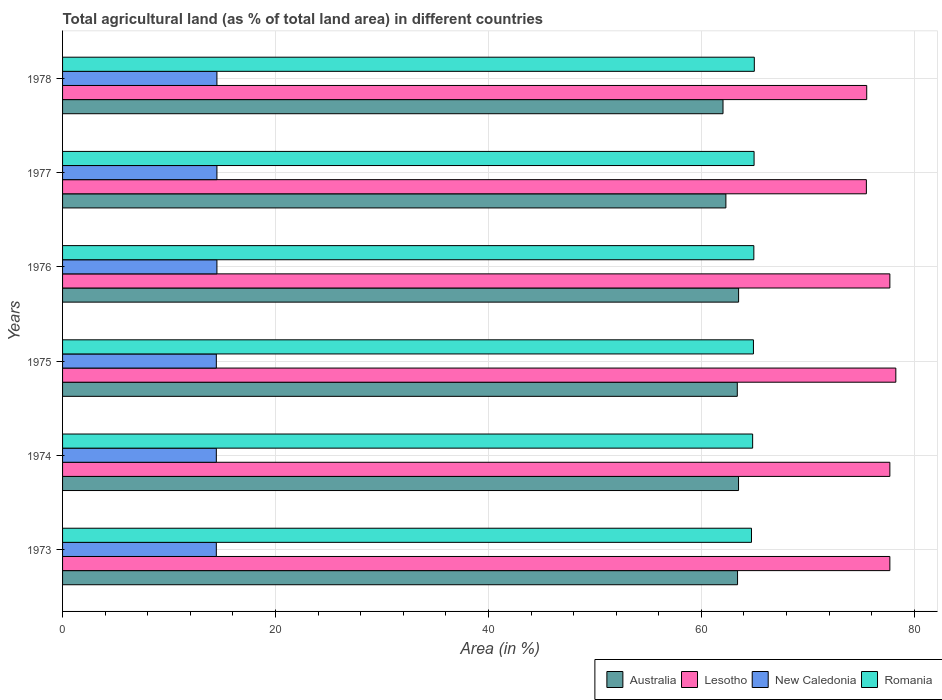How many bars are there on the 4th tick from the bottom?
Your response must be concise. 4. What is the label of the 1st group of bars from the top?
Your answer should be compact. 1978. What is the percentage of agricultural land in New Caledonia in 1975?
Your answer should be very brief. 14.44. Across all years, what is the maximum percentage of agricultural land in Lesotho?
Provide a short and direct response. 78.26. Across all years, what is the minimum percentage of agricultural land in Romania?
Offer a very short reply. 64.7. In which year was the percentage of agricultural land in Lesotho maximum?
Provide a short and direct response. 1975. In which year was the percentage of agricultural land in Australia minimum?
Make the answer very short. 1978. What is the total percentage of agricultural land in New Caledonia in the graph?
Keep it short and to the point. 86.82. What is the difference between the percentage of agricultural land in Australia in 1975 and that in 1978?
Offer a terse response. 1.34. What is the difference between the percentage of agricultural land in Romania in 1976 and the percentage of agricultural land in Australia in 1974?
Make the answer very short. 1.44. What is the average percentage of agricultural land in Lesotho per year?
Provide a succinct answer. 77.06. In the year 1976, what is the difference between the percentage of agricultural land in Australia and percentage of agricultural land in Romania?
Your answer should be very brief. -1.43. What is the ratio of the percentage of agricultural land in Australia in 1973 to that in 1978?
Offer a very short reply. 1.02. Is the percentage of agricultural land in Australia in 1975 less than that in 1978?
Your answer should be very brief. No. Is the difference between the percentage of agricultural land in Australia in 1977 and 1978 greater than the difference between the percentage of agricultural land in Romania in 1977 and 1978?
Your response must be concise. Yes. What is the difference between the highest and the second highest percentage of agricultural land in Australia?
Provide a short and direct response. 0.01. What is the difference between the highest and the lowest percentage of agricultural land in Australia?
Provide a short and direct response. 1.46. Is the sum of the percentage of agricultural land in Lesotho in 1976 and 1977 greater than the maximum percentage of agricultural land in Australia across all years?
Offer a terse response. Yes. What does the 2nd bar from the bottom in 1973 represents?
Give a very brief answer. Lesotho. Is it the case that in every year, the sum of the percentage of agricultural land in Australia and percentage of agricultural land in New Caledonia is greater than the percentage of agricultural land in Lesotho?
Your answer should be compact. No. Are the values on the major ticks of X-axis written in scientific E-notation?
Your answer should be very brief. No. Does the graph contain any zero values?
Your answer should be very brief. No. How many legend labels are there?
Your answer should be very brief. 4. What is the title of the graph?
Offer a very short reply. Total agricultural land (as % of total land area) in different countries. What is the label or title of the X-axis?
Your answer should be compact. Area (in %). What is the Area (in %) of Australia in 1973?
Ensure brevity in your answer.  63.39. What is the Area (in %) in Lesotho in 1973?
Offer a terse response. 77.7. What is the Area (in %) in New Caledonia in 1973?
Keep it short and to the point. 14.44. What is the Area (in %) of Romania in 1973?
Keep it short and to the point. 64.7. What is the Area (in %) in Australia in 1974?
Your answer should be compact. 63.49. What is the Area (in %) in Lesotho in 1974?
Provide a short and direct response. 77.7. What is the Area (in %) in New Caledonia in 1974?
Your answer should be compact. 14.44. What is the Area (in %) in Romania in 1974?
Offer a very short reply. 64.81. What is the Area (in %) of Australia in 1975?
Your answer should be compact. 63.37. What is the Area (in %) of Lesotho in 1975?
Your response must be concise. 78.26. What is the Area (in %) in New Caledonia in 1975?
Your response must be concise. 14.44. What is the Area (in %) in Romania in 1975?
Your response must be concise. 64.89. What is the Area (in %) of Australia in 1976?
Keep it short and to the point. 63.49. What is the Area (in %) in Lesotho in 1976?
Keep it short and to the point. 77.7. What is the Area (in %) in New Caledonia in 1976?
Give a very brief answer. 14.5. What is the Area (in %) in Romania in 1976?
Your response must be concise. 64.93. What is the Area (in %) in Australia in 1977?
Provide a succinct answer. 62.3. What is the Area (in %) of Lesotho in 1977?
Your answer should be compact. 75.49. What is the Area (in %) in New Caledonia in 1977?
Your answer should be compact. 14.5. What is the Area (in %) of Romania in 1977?
Make the answer very short. 64.95. What is the Area (in %) in Australia in 1978?
Provide a succinct answer. 62.03. What is the Area (in %) of Lesotho in 1978?
Offer a terse response. 75.53. What is the Area (in %) in New Caledonia in 1978?
Provide a succinct answer. 14.5. What is the Area (in %) of Romania in 1978?
Provide a succinct answer. 64.97. Across all years, what is the maximum Area (in %) of Australia?
Your response must be concise. 63.49. Across all years, what is the maximum Area (in %) in Lesotho?
Give a very brief answer. 78.26. Across all years, what is the maximum Area (in %) in New Caledonia?
Your answer should be compact. 14.5. Across all years, what is the maximum Area (in %) in Romania?
Make the answer very short. 64.97. Across all years, what is the minimum Area (in %) of Australia?
Give a very brief answer. 62.03. Across all years, what is the minimum Area (in %) of Lesotho?
Keep it short and to the point. 75.49. Across all years, what is the minimum Area (in %) of New Caledonia?
Provide a succinct answer. 14.44. Across all years, what is the minimum Area (in %) of Romania?
Your answer should be very brief. 64.7. What is the total Area (in %) in Australia in the graph?
Provide a short and direct response. 378.08. What is the total Area (in %) of Lesotho in the graph?
Your answer should be compact. 462.38. What is the total Area (in %) in New Caledonia in the graph?
Offer a terse response. 86.82. What is the total Area (in %) of Romania in the graph?
Ensure brevity in your answer.  389.25. What is the difference between the Area (in %) in Australia in 1973 and that in 1974?
Offer a very short reply. -0.09. What is the difference between the Area (in %) in Lesotho in 1973 and that in 1974?
Make the answer very short. 0. What is the difference between the Area (in %) of Romania in 1973 and that in 1974?
Ensure brevity in your answer.  -0.11. What is the difference between the Area (in %) of Australia in 1973 and that in 1975?
Keep it short and to the point. 0.02. What is the difference between the Area (in %) in Lesotho in 1973 and that in 1975?
Provide a short and direct response. -0.56. What is the difference between the Area (in %) in New Caledonia in 1973 and that in 1975?
Keep it short and to the point. 0. What is the difference between the Area (in %) in Romania in 1973 and that in 1975?
Offer a very short reply. -0.18. What is the difference between the Area (in %) of Australia in 1973 and that in 1976?
Keep it short and to the point. -0.1. What is the difference between the Area (in %) in New Caledonia in 1973 and that in 1976?
Provide a succinct answer. -0.05. What is the difference between the Area (in %) of Romania in 1973 and that in 1976?
Make the answer very short. -0.22. What is the difference between the Area (in %) of Australia in 1973 and that in 1977?
Give a very brief answer. 1.09. What is the difference between the Area (in %) in Lesotho in 1973 and that in 1977?
Keep it short and to the point. 2.21. What is the difference between the Area (in %) in New Caledonia in 1973 and that in 1977?
Your response must be concise. -0.05. What is the difference between the Area (in %) of Romania in 1973 and that in 1977?
Keep it short and to the point. -0.24. What is the difference between the Area (in %) in Australia in 1973 and that in 1978?
Offer a terse response. 1.37. What is the difference between the Area (in %) in Lesotho in 1973 and that in 1978?
Your answer should be compact. 2.17. What is the difference between the Area (in %) of New Caledonia in 1973 and that in 1978?
Offer a terse response. -0.05. What is the difference between the Area (in %) in Romania in 1973 and that in 1978?
Make the answer very short. -0.26. What is the difference between the Area (in %) of Australia in 1974 and that in 1975?
Offer a terse response. 0.12. What is the difference between the Area (in %) in Lesotho in 1974 and that in 1975?
Give a very brief answer. -0.56. What is the difference between the Area (in %) in Romania in 1974 and that in 1975?
Provide a succinct answer. -0.07. What is the difference between the Area (in %) in Australia in 1974 and that in 1976?
Provide a short and direct response. -0.01. What is the difference between the Area (in %) in New Caledonia in 1974 and that in 1976?
Provide a succinct answer. -0.05. What is the difference between the Area (in %) of Romania in 1974 and that in 1976?
Make the answer very short. -0.11. What is the difference between the Area (in %) in Australia in 1974 and that in 1977?
Make the answer very short. 1.19. What is the difference between the Area (in %) of Lesotho in 1974 and that in 1977?
Give a very brief answer. 2.21. What is the difference between the Area (in %) in New Caledonia in 1974 and that in 1977?
Offer a very short reply. -0.05. What is the difference between the Area (in %) in Romania in 1974 and that in 1977?
Ensure brevity in your answer.  -0.13. What is the difference between the Area (in %) of Australia in 1974 and that in 1978?
Offer a terse response. 1.46. What is the difference between the Area (in %) in Lesotho in 1974 and that in 1978?
Keep it short and to the point. 2.17. What is the difference between the Area (in %) in New Caledonia in 1974 and that in 1978?
Your answer should be very brief. -0.05. What is the difference between the Area (in %) of Romania in 1974 and that in 1978?
Ensure brevity in your answer.  -0.16. What is the difference between the Area (in %) of Australia in 1975 and that in 1976?
Give a very brief answer. -0.12. What is the difference between the Area (in %) in Lesotho in 1975 and that in 1976?
Your answer should be very brief. 0.56. What is the difference between the Area (in %) in New Caledonia in 1975 and that in 1976?
Give a very brief answer. -0.05. What is the difference between the Area (in %) in Romania in 1975 and that in 1976?
Make the answer very short. -0.04. What is the difference between the Area (in %) of Australia in 1975 and that in 1977?
Offer a very short reply. 1.07. What is the difference between the Area (in %) of Lesotho in 1975 and that in 1977?
Your answer should be very brief. 2.77. What is the difference between the Area (in %) in New Caledonia in 1975 and that in 1977?
Give a very brief answer. -0.05. What is the difference between the Area (in %) in Romania in 1975 and that in 1977?
Ensure brevity in your answer.  -0.06. What is the difference between the Area (in %) in Australia in 1975 and that in 1978?
Offer a terse response. 1.34. What is the difference between the Area (in %) of Lesotho in 1975 and that in 1978?
Offer a terse response. 2.73. What is the difference between the Area (in %) of New Caledonia in 1975 and that in 1978?
Make the answer very short. -0.05. What is the difference between the Area (in %) in Romania in 1975 and that in 1978?
Your answer should be compact. -0.08. What is the difference between the Area (in %) in Australia in 1976 and that in 1977?
Provide a short and direct response. 1.19. What is the difference between the Area (in %) in Lesotho in 1976 and that in 1977?
Your response must be concise. 2.21. What is the difference between the Area (in %) of New Caledonia in 1976 and that in 1977?
Your response must be concise. 0. What is the difference between the Area (in %) in Romania in 1976 and that in 1977?
Keep it short and to the point. -0.02. What is the difference between the Area (in %) in Australia in 1976 and that in 1978?
Provide a succinct answer. 1.46. What is the difference between the Area (in %) in Lesotho in 1976 and that in 1978?
Offer a terse response. 2.17. What is the difference between the Area (in %) in New Caledonia in 1976 and that in 1978?
Give a very brief answer. 0. What is the difference between the Area (in %) of Romania in 1976 and that in 1978?
Provide a short and direct response. -0.04. What is the difference between the Area (in %) of Australia in 1977 and that in 1978?
Give a very brief answer. 0.27. What is the difference between the Area (in %) of Lesotho in 1977 and that in 1978?
Provide a succinct answer. -0.03. What is the difference between the Area (in %) of Romania in 1977 and that in 1978?
Ensure brevity in your answer.  -0.02. What is the difference between the Area (in %) of Australia in 1973 and the Area (in %) of Lesotho in 1974?
Your response must be concise. -14.31. What is the difference between the Area (in %) in Australia in 1973 and the Area (in %) in New Caledonia in 1974?
Your response must be concise. 48.95. What is the difference between the Area (in %) of Australia in 1973 and the Area (in %) of Romania in 1974?
Provide a short and direct response. -1.42. What is the difference between the Area (in %) of Lesotho in 1973 and the Area (in %) of New Caledonia in 1974?
Keep it short and to the point. 63.26. What is the difference between the Area (in %) of Lesotho in 1973 and the Area (in %) of Romania in 1974?
Keep it short and to the point. 12.89. What is the difference between the Area (in %) of New Caledonia in 1973 and the Area (in %) of Romania in 1974?
Provide a succinct answer. -50.37. What is the difference between the Area (in %) of Australia in 1973 and the Area (in %) of Lesotho in 1975?
Your answer should be compact. -14.87. What is the difference between the Area (in %) in Australia in 1973 and the Area (in %) in New Caledonia in 1975?
Make the answer very short. 48.95. What is the difference between the Area (in %) in Australia in 1973 and the Area (in %) in Romania in 1975?
Offer a terse response. -1.49. What is the difference between the Area (in %) of Lesotho in 1973 and the Area (in %) of New Caledonia in 1975?
Provide a short and direct response. 63.26. What is the difference between the Area (in %) of Lesotho in 1973 and the Area (in %) of Romania in 1975?
Make the answer very short. 12.81. What is the difference between the Area (in %) in New Caledonia in 1973 and the Area (in %) in Romania in 1975?
Provide a succinct answer. -50.44. What is the difference between the Area (in %) of Australia in 1973 and the Area (in %) of Lesotho in 1976?
Offer a very short reply. -14.31. What is the difference between the Area (in %) of Australia in 1973 and the Area (in %) of New Caledonia in 1976?
Give a very brief answer. 48.9. What is the difference between the Area (in %) in Australia in 1973 and the Area (in %) in Romania in 1976?
Provide a succinct answer. -1.53. What is the difference between the Area (in %) in Lesotho in 1973 and the Area (in %) in New Caledonia in 1976?
Provide a short and direct response. 63.2. What is the difference between the Area (in %) of Lesotho in 1973 and the Area (in %) of Romania in 1976?
Give a very brief answer. 12.78. What is the difference between the Area (in %) in New Caledonia in 1973 and the Area (in %) in Romania in 1976?
Make the answer very short. -50.48. What is the difference between the Area (in %) of Australia in 1973 and the Area (in %) of Lesotho in 1977?
Offer a terse response. -12.1. What is the difference between the Area (in %) of Australia in 1973 and the Area (in %) of New Caledonia in 1977?
Your answer should be very brief. 48.9. What is the difference between the Area (in %) in Australia in 1973 and the Area (in %) in Romania in 1977?
Make the answer very short. -1.55. What is the difference between the Area (in %) in Lesotho in 1973 and the Area (in %) in New Caledonia in 1977?
Your answer should be very brief. 63.2. What is the difference between the Area (in %) of Lesotho in 1973 and the Area (in %) of Romania in 1977?
Keep it short and to the point. 12.75. What is the difference between the Area (in %) of New Caledonia in 1973 and the Area (in %) of Romania in 1977?
Provide a short and direct response. -50.51. What is the difference between the Area (in %) in Australia in 1973 and the Area (in %) in Lesotho in 1978?
Keep it short and to the point. -12.13. What is the difference between the Area (in %) in Australia in 1973 and the Area (in %) in New Caledonia in 1978?
Your response must be concise. 48.9. What is the difference between the Area (in %) in Australia in 1973 and the Area (in %) in Romania in 1978?
Offer a terse response. -1.57. What is the difference between the Area (in %) in Lesotho in 1973 and the Area (in %) in New Caledonia in 1978?
Your answer should be compact. 63.2. What is the difference between the Area (in %) in Lesotho in 1973 and the Area (in %) in Romania in 1978?
Your answer should be compact. 12.73. What is the difference between the Area (in %) in New Caledonia in 1973 and the Area (in %) in Romania in 1978?
Give a very brief answer. -50.53. What is the difference between the Area (in %) in Australia in 1974 and the Area (in %) in Lesotho in 1975?
Make the answer very short. -14.77. What is the difference between the Area (in %) of Australia in 1974 and the Area (in %) of New Caledonia in 1975?
Ensure brevity in your answer.  49.05. What is the difference between the Area (in %) of Australia in 1974 and the Area (in %) of Romania in 1975?
Your response must be concise. -1.4. What is the difference between the Area (in %) of Lesotho in 1974 and the Area (in %) of New Caledonia in 1975?
Your answer should be compact. 63.26. What is the difference between the Area (in %) of Lesotho in 1974 and the Area (in %) of Romania in 1975?
Make the answer very short. 12.81. What is the difference between the Area (in %) of New Caledonia in 1974 and the Area (in %) of Romania in 1975?
Provide a succinct answer. -50.44. What is the difference between the Area (in %) in Australia in 1974 and the Area (in %) in Lesotho in 1976?
Provide a succinct answer. -14.21. What is the difference between the Area (in %) in Australia in 1974 and the Area (in %) in New Caledonia in 1976?
Offer a very short reply. 48.99. What is the difference between the Area (in %) of Australia in 1974 and the Area (in %) of Romania in 1976?
Offer a very short reply. -1.44. What is the difference between the Area (in %) in Lesotho in 1974 and the Area (in %) in New Caledonia in 1976?
Your answer should be compact. 63.2. What is the difference between the Area (in %) in Lesotho in 1974 and the Area (in %) in Romania in 1976?
Ensure brevity in your answer.  12.78. What is the difference between the Area (in %) of New Caledonia in 1974 and the Area (in %) of Romania in 1976?
Provide a succinct answer. -50.48. What is the difference between the Area (in %) in Australia in 1974 and the Area (in %) in Lesotho in 1977?
Your response must be concise. -12.01. What is the difference between the Area (in %) of Australia in 1974 and the Area (in %) of New Caledonia in 1977?
Provide a short and direct response. 48.99. What is the difference between the Area (in %) of Australia in 1974 and the Area (in %) of Romania in 1977?
Offer a very short reply. -1.46. What is the difference between the Area (in %) of Lesotho in 1974 and the Area (in %) of New Caledonia in 1977?
Make the answer very short. 63.2. What is the difference between the Area (in %) of Lesotho in 1974 and the Area (in %) of Romania in 1977?
Offer a very short reply. 12.75. What is the difference between the Area (in %) in New Caledonia in 1974 and the Area (in %) in Romania in 1977?
Offer a terse response. -50.51. What is the difference between the Area (in %) in Australia in 1974 and the Area (in %) in Lesotho in 1978?
Your answer should be very brief. -12.04. What is the difference between the Area (in %) of Australia in 1974 and the Area (in %) of New Caledonia in 1978?
Offer a terse response. 48.99. What is the difference between the Area (in %) of Australia in 1974 and the Area (in %) of Romania in 1978?
Provide a succinct answer. -1.48. What is the difference between the Area (in %) in Lesotho in 1974 and the Area (in %) in New Caledonia in 1978?
Offer a terse response. 63.2. What is the difference between the Area (in %) of Lesotho in 1974 and the Area (in %) of Romania in 1978?
Provide a short and direct response. 12.73. What is the difference between the Area (in %) of New Caledonia in 1974 and the Area (in %) of Romania in 1978?
Offer a very short reply. -50.53. What is the difference between the Area (in %) of Australia in 1975 and the Area (in %) of Lesotho in 1976?
Offer a very short reply. -14.33. What is the difference between the Area (in %) in Australia in 1975 and the Area (in %) in New Caledonia in 1976?
Keep it short and to the point. 48.87. What is the difference between the Area (in %) in Australia in 1975 and the Area (in %) in Romania in 1976?
Your answer should be very brief. -1.55. What is the difference between the Area (in %) of Lesotho in 1975 and the Area (in %) of New Caledonia in 1976?
Ensure brevity in your answer.  63.76. What is the difference between the Area (in %) of Lesotho in 1975 and the Area (in %) of Romania in 1976?
Provide a succinct answer. 13.34. What is the difference between the Area (in %) of New Caledonia in 1975 and the Area (in %) of Romania in 1976?
Your answer should be compact. -50.48. What is the difference between the Area (in %) of Australia in 1975 and the Area (in %) of Lesotho in 1977?
Offer a very short reply. -12.12. What is the difference between the Area (in %) in Australia in 1975 and the Area (in %) in New Caledonia in 1977?
Your response must be concise. 48.87. What is the difference between the Area (in %) in Australia in 1975 and the Area (in %) in Romania in 1977?
Provide a succinct answer. -1.58. What is the difference between the Area (in %) in Lesotho in 1975 and the Area (in %) in New Caledonia in 1977?
Keep it short and to the point. 63.76. What is the difference between the Area (in %) of Lesotho in 1975 and the Area (in %) of Romania in 1977?
Offer a terse response. 13.31. What is the difference between the Area (in %) of New Caledonia in 1975 and the Area (in %) of Romania in 1977?
Provide a short and direct response. -50.51. What is the difference between the Area (in %) in Australia in 1975 and the Area (in %) in Lesotho in 1978?
Provide a succinct answer. -12.16. What is the difference between the Area (in %) of Australia in 1975 and the Area (in %) of New Caledonia in 1978?
Make the answer very short. 48.87. What is the difference between the Area (in %) of Australia in 1975 and the Area (in %) of Romania in 1978?
Give a very brief answer. -1.6. What is the difference between the Area (in %) in Lesotho in 1975 and the Area (in %) in New Caledonia in 1978?
Offer a very short reply. 63.76. What is the difference between the Area (in %) of Lesotho in 1975 and the Area (in %) of Romania in 1978?
Provide a short and direct response. 13.29. What is the difference between the Area (in %) of New Caledonia in 1975 and the Area (in %) of Romania in 1978?
Provide a succinct answer. -50.53. What is the difference between the Area (in %) in Australia in 1976 and the Area (in %) in Lesotho in 1977?
Your answer should be compact. -12. What is the difference between the Area (in %) in Australia in 1976 and the Area (in %) in New Caledonia in 1977?
Make the answer very short. 49. What is the difference between the Area (in %) of Australia in 1976 and the Area (in %) of Romania in 1977?
Your answer should be compact. -1.45. What is the difference between the Area (in %) in Lesotho in 1976 and the Area (in %) in New Caledonia in 1977?
Offer a terse response. 63.2. What is the difference between the Area (in %) in Lesotho in 1976 and the Area (in %) in Romania in 1977?
Provide a succinct answer. 12.75. What is the difference between the Area (in %) of New Caledonia in 1976 and the Area (in %) of Romania in 1977?
Your response must be concise. -50.45. What is the difference between the Area (in %) in Australia in 1976 and the Area (in %) in Lesotho in 1978?
Your answer should be very brief. -12.03. What is the difference between the Area (in %) of Australia in 1976 and the Area (in %) of New Caledonia in 1978?
Your answer should be compact. 49. What is the difference between the Area (in %) of Australia in 1976 and the Area (in %) of Romania in 1978?
Your response must be concise. -1.48. What is the difference between the Area (in %) in Lesotho in 1976 and the Area (in %) in New Caledonia in 1978?
Ensure brevity in your answer.  63.2. What is the difference between the Area (in %) in Lesotho in 1976 and the Area (in %) in Romania in 1978?
Ensure brevity in your answer.  12.73. What is the difference between the Area (in %) of New Caledonia in 1976 and the Area (in %) of Romania in 1978?
Make the answer very short. -50.47. What is the difference between the Area (in %) in Australia in 1977 and the Area (in %) in Lesotho in 1978?
Keep it short and to the point. -13.23. What is the difference between the Area (in %) in Australia in 1977 and the Area (in %) in New Caledonia in 1978?
Your response must be concise. 47.8. What is the difference between the Area (in %) in Australia in 1977 and the Area (in %) in Romania in 1978?
Offer a very short reply. -2.67. What is the difference between the Area (in %) in Lesotho in 1977 and the Area (in %) in New Caledonia in 1978?
Keep it short and to the point. 61. What is the difference between the Area (in %) of Lesotho in 1977 and the Area (in %) of Romania in 1978?
Make the answer very short. 10.52. What is the difference between the Area (in %) of New Caledonia in 1977 and the Area (in %) of Romania in 1978?
Your answer should be compact. -50.47. What is the average Area (in %) of Australia per year?
Ensure brevity in your answer.  63.01. What is the average Area (in %) in Lesotho per year?
Your answer should be very brief. 77.06. What is the average Area (in %) of New Caledonia per year?
Make the answer very short. 14.47. What is the average Area (in %) of Romania per year?
Offer a terse response. 64.87. In the year 1973, what is the difference between the Area (in %) of Australia and Area (in %) of Lesotho?
Your response must be concise. -14.31. In the year 1973, what is the difference between the Area (in %) in Australia and Area (in %) in New Caledonia?
Your answer should be compact. 48.95. In the year 1973, what is the difference between the Area (in %) in Australia and Area (in %) in Romania?
Your answer should be compact. -1.31. In the year 1973, what is the difference between the Area (in %) of Lesotho and Area (in %) of New Caledonia?
Offer a very short reply. 63.26. In the year 1973, what is the difference between the Area (in %) in Lesotho and Area (in %) in Romania?
Give a very brief answer. 13. In the year 1973, what is the difference between the Area (in %) in New Caledonia and Area (in %) in Romania?
Provide a short and direct response. -50.26. In the year 1974, what is the difference between the Area (in %) in Australia and Area (in %) in Lesotho?
Ensure brevity in your answer.  -14.21. In the year 1974, what is the difference between the Area (in %) in Australia and Area (in %) in New Caledonia?
Make the answer very short. 49.05. In the year 1974, what is the difference between the Area (in %) in Australia and Area (in %) in Romania?
Keep it short and to the point. -1.33. In the year 1974, what is the difference between the Area (in %) of Lesotho and Area (in %) of New Caledonia?
Make the answer very short. 63.26. In the year 1974, what is the difference between the Area (in %) of Lesotho and Area (in %) of Romania?
Provide a short and direct response. 12.89. In the year 1974, what is the difference between the Area (in %) of New Caledonia and Area (in %) of Romania?
Your response must be concise. -50.37. In the year 1975, what is the difference between the Area (in %) in Australia and Area (in %) in Lesotho?
Offer a very short reply. -14.89. In the year 1975, what is the difference between the Area (in %) of Australia and Area (in %) of New Caledonia?
Offer a terse response. 48.93. In the year 1975, what is the difference between the Area (in %) in Australia and Area (in %) in Romania?
Give a very brief answer. -1.52. In the year 1975, what is the difference between the Area (in %) of Lesotho and Area (in %) of New Caledonia?
Offer a terse response. 63.82. In the year 1975, what is the difference between the Area (in %) of Lesotho and Area (in %) of Romania?
Keep it short and to the point. 13.37. In the year 1975, what is the difference between the Area (in %) in New Caledonia and Area (in %) in Romania?
Keep it short and to the point. -50.44. In the year 1976, what is the difference between the Area (in %) of Australia and Area (in %) of Lesotho?
Give a very brief answer. -14.21. In the year 1976, what is the difference between the Area (in %) in Australia and Area (in %) in New Caledonia?
Make the answer very short. 49. In the year 1976, what is the difference between the Area (in %) in Australia and Area (in %) in Romania?
Your answer should be very brief. -1.43. In the year 1976, what is the difference between the Area (in %) of Lesotho and Area (in %) of New Caledonia?
Offer a terse response. 63.2. In the year 1976, what is the difference between the Area (in %) in Lesotho and Area (in %) in Romania?
Make the answer very short. 12.78. In the year 1976, what is the difference between the Area (in %) of New Caledonia and Area (in %) of Romania?
Make the answer very short. -50.43. In the year 1977, what is the difference between the Area (in %) of Australia and Area (in %) of Lesotho?
Keep it short and to the point. -13.19. In the year 1977, what is the difference between the Area (in %) in Australia and Area (in %) in New Caledonia?
Your response must be concise. 47.8. In the year 1977, what is the difference between the Area (in %) in Australia and Area (in %) in Romania?
Your answer should be very brief. -2.65. In the year 1977, what is the difference between the Area (in %) in Lesotho and Area (in %) in New Caledonia?
Offer a terse response. 61. In the year 1977, what is the difference between the Area (in %) of Lesotho and Area (in %) of Romania?
Offer a very short reply. 10.55. In the year 1977, what is the difference between the Area (in %) of New Caledonia and Area (in %) of Romania?
Ensure brevity in your answer.  -50.45. In the year 1978, what is the difference between the Area (in %) of Australia and Area (in %) of Lesotho?
Make the answer very short. -13.5. In the year 1978, what is the difference between the Area (in %) in Australia and Area (in %) in New Caledonia?
Make the answer very short. 47.53. In the year 1978, what is the difference between the Area (in %) in Australia and Area (in %) in Romania?
Give a very brief answer. -2.94. In the year 1978, what is the difference between the Area (in %) in Lesotho and Area (in %) in New Caledonia?
Make the answer very short. 61.03. In the year 1978, what is the difference between the Area (in %) in Lesotho and Area (in %) in Romania?
Provide a succinct answer. 10.56. In the year 1978, what is the difference between the Area (in %) in New Caledonia and Area (in %) in Romania?
Your answer should be very brief. -50.47. What is the ratio of the Area (in %) in Australia in 1973 to that in 1974?
Your answer should be very brief. 1. What is the ratio of the Area (in %) in Lesotho in 1973 to that in 1974?
Your answer should be compact. 1. What is the ratio of the Area (in %) of New Caledonia in 1973 to that in 1974?
Offer a very short reply. 1. What is the ratio of the Area (in %) in Australia in 1973 to that in 1975?
Your answer should be compact. 1. What is the ratio of the Area (in %) of Lesotho in 1973 to that in 1975?
Your answer should be compact. 0.99. What is the ratio of the Area (in %) in New Caledonia in 1973 to that in 1975?
Ensure brevity in your answer.  1. What is the ratio of the Area (in %) in Lesotho in 1973 to that in 1976?
Make the answer very short. 1. What is the ratio of the Area (in %) in New Caledonia in 1973 to that in 1976?
Your answer should be very brief. 1. What is the ratio of the Area (in %) in Romania in 1973 to that in 1976?
Provide a short and direct response. 1. What is the ratio of the Area (in %) of Australia in 1973 to that in 1977?
Give a very brief answer. 1.02. What is the ratio of the Area (in %) in Lesotho in 1973 to that in 1977?
Make the answer very short. 1.03. What is the ratio of the Area (in %) in Lesotho in 1973 to that in 1978?
Provide a succinct answer. 1.03. What is the ratio of the Area (in %) of Australia in 1974 to that in 1975?
Offer a very short reply. 1. What is the ratio of the Area (in %) in Lesotho in 1974 to that in 1975?
Give a very brief answer. 0.99. What is the ratio of the Area (in %) of New Caledonia in 1974 to that in 1975?
Offer a terse response. 1. What is the ratio of the Area (in %) in Romania in 1974 to that in 1976?
Offer a terse response. 1. What is the ratio of the Area (in %) of Lesotho in 1974 to that in 1977?
Keep it short and to the point. 1.03. What is the ratio of the Area (in %) in New Caledonia in 1974 to that in 1977?
Your answer should be very brief. 1. What is the ratio of the Area (in %) of Romania in 1974 to that in 1977?
Keep it short and to the point. 1. What is the ratio of the Area (in %) in Australia in 1974 to that in 1978?
Your response must be concise. 1.02. What is the ratio of the Area (in %) in Lesotho in 1974 to that in 1978?
Your answer should be compact. 1.03. What is the ratio of the Area (in %) in Lesotho in 1975 to that in 1976?
Give a very brief answer. 1.01. What is the ratio of the Area (in %) of Romania in 1975 to that in 1976?
Your answer should be very brief. 1. What is the ratio of the Area (in %) of Australia in 1975 to that in 1977?
Provide a short and direct response. 1.02. What is the ratio of the Area (in %) in Lesotho in 1975 to that in 1977?
Give a very brief answer. 1.04. What is the ratio of the Area (in %) of Romania in 1975 to that in 1977?
Your answer should be very brief. 1. What is the ratio of the Area (in %) of Australia in 1975 to that in 1978?
Your response must be concise. 1.02. What is the ratio of the Area (in %) in Lesotho in 1975 to that in 1978?
Offer a terse response. 1.04. What is the ratio of the Area (in %) in Australia in 1976 to that in 1977?
Keep it short and to the point. 1.02. What is the ratio of the Area (in %) in Lesotho in 1976 to that in 1977?
Offer a very short reply. 1.03. What is the ratio of the Area (in %) of Romania in 1976 to that in 1977?
Provide a succinct answer. 1. What is the ratio of the Area (in %) of Australia in 1976 to that in 1978?
Offer a very short reply. 1.02. What is the ratio of the Area (in %) in Lesotho in 1976 to that in 1978?
Your response must be concise. 1.03. What is the ratio of the Area (in %) of New Caledonia in 1976 to that in 1978?
Offer a terse response. 1. What is the ratio of the Area (in %) of Australia in 1977 to that in 1978?
Ensure brevity in your answer.  1. What is the ratio of the Area (in %) of New Caledonia in 1977 to that in 1978?
Ensure brevity in your answer.  1. What is the ratio of the Area (in %) in Romania in 1977 to that in 1978?
Keep it short and to the point. 1. What is the difference between the highest and the second highest Area (in %) of Australia?
Make the answer very short. 0.01. What is the difference between the highest and the second highest Area (in %) of Lesotho?
Your answer should be compact. 0.56. What is the difference between the highest and the second highest Area (in %) of Romania?
Make the answer very short. 0.02. What is the difference between the highest and the lowest Area (in %) of Australia?
Make the answer very short. 1.46. What is the difference between the highest and the lowest Area (in %) of Lesotho?
Keep it short and to the point. 2.77. What is the difference between the highest and the lowest Area (in %) of New Caledonia?
Make the answer very short. 0.05. What is the difference between the highest and the lowest Area (in %) in Romania?
Offer a very short reply. 0.26. 